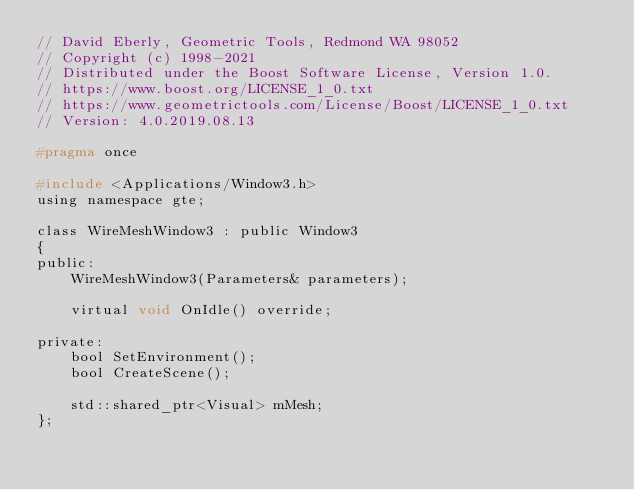<code> <loc_0><loc_0><loc_500><loc_500><_C_>// David Eberly, Geometric Tools, Redmond WA 98052
// Copyright (c) 1998-2021
// Distributed under the Boost Software License, Version 1.0.
// https://www.boost.org/LICENSE_1_0.txt
// https://www.geometrictools.com/License/Boost/LICENSE_1_0.txt
// Version: 4.0.2019.08.13

#pragma once

#include <Applications/Window3.h>
using namespace gte;

class WireMeshWindow3 : public Window3
{
public:
    WireMeshWindow3(Parameters& parameters);

    virtual void OnIdle() override;

private:
    bool SetEnvironment();
    bool CreateScene();

    std::shared_ptr<Visual> mMesh;
};
</code> 